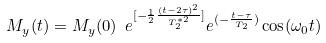Convert formula to latex. <formula><loc_0><loc_0><loc_500><loc_500>M _ { y } ( t ) = M _ { y } ( 0 ) \ e ^ { [ { - \frac { 1 } { 2 } \frac { ( t - 2 \tau ) ^ { 2 } } { T _ { 2 } ^ { * 2 } } } ] } e ^ { ( { - \frac { t - \tau } { T _ { 2 } } } ) } \cos ( \omega _ { 0 } t )</formula> 